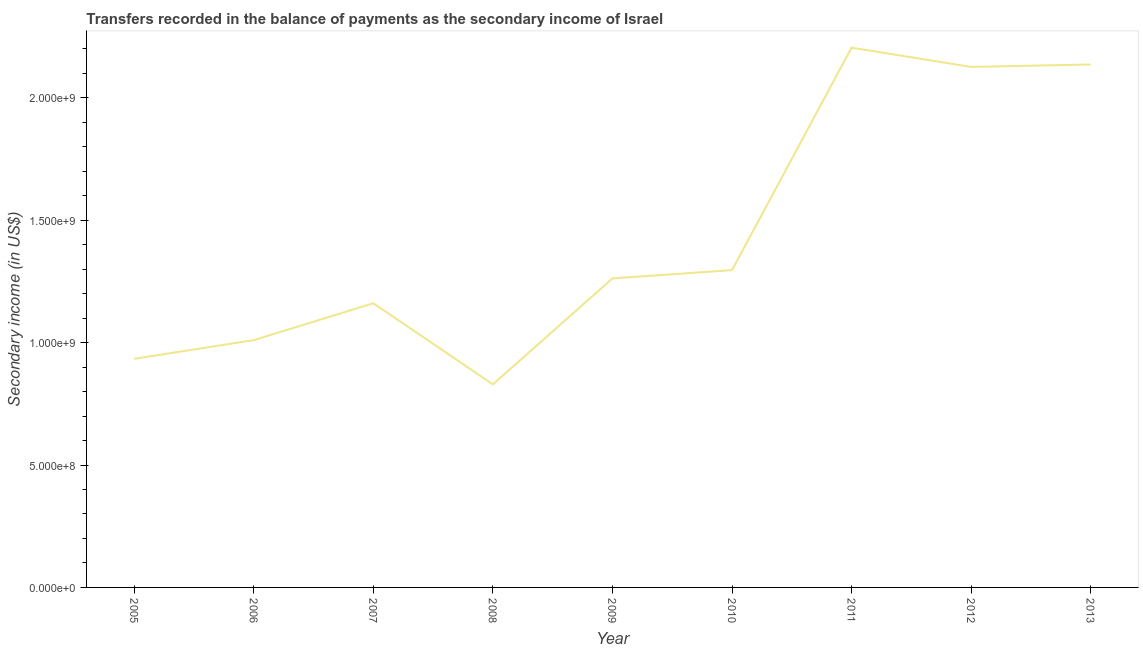What is the amount of secondary income in 2006?
Your response must be concise. 1.01e+09. Across all years, what is the maximum amount of secondary income?
Your answer should be compact. 2.21e+09. Across all years, what is the minimum amount of secondary income?
Provide a short and direct response. 8.30e+08. In which year was the amount of secondary income maximum?
Provide a short and direct response. 2011. What is the sum of the amount of secondary income?
Your response must be concise. 1.30e+1. What is the difference between the amount of secondary income in 2006 and 2007?
Offer a terse response. -1.51e+08. What is the average amount of secondary income per year?
Your answer should be compact. 1.44e+09. What is the median amount of secondary income?
Offer a very short reply. 1.26e+09. In how many years, is the amount of secondary income greater than 200000000 US$?
Give a very brief answer. 9. What is the ratio of the amount of secondary income in 2007 to that in 2011?
Give a very brief answer. 0.53. What is the difference between the highest and the second highest amount of secondary income?
Provide a succinct answer. 6.87e+07. Is the sum of the amount of secondary income in 2009 and 2012 greater than the maximum amount of secondary income across all years?
Offer a very short reply. Yes. What is the difference between the highest and the lowest amount of secondary income?
Your answer should be compact. 1.38e+09. In how many years, is the amount of secondary income greater than the average amount of secondary income taken over all years?
Make the answer very short. 3. What is the difference between two consecutive major ticks on the Y-axis?
Ensure brevity in your answer.  5.00e+08. Are the values on the major ticks of Y-axis written in scientific E-notation?
Keep it short and to the point. Yes. What is the title of the graph?
Ensure brevity in your answer.  Transfers recorded in the balance of payments as the secondary income of Israel. What is the label or title of the Y-axis?
Keep it short and to the point. Secondary income (in US$). What is the Secondary income (in US$) in 2005?
Your answer should be compact. 9.34e+08. What is the Secondary income (in US$) in 2006?
Keep it short and to the point. 1.01e+09. What is the Secondary income (in US$) of 2007?
Your answer should be very brief. 1.16e+09. What is the Secondary income (in US$) in 2008?
Your answer should be compact. 8.30e+08. What is the Secondary income (in US$) of 2009?
Your response must be concise. 1.26e+09. What is the Secondary income (in US$) in 2010?
Provide a succinct answer. 1.30e+09. What is the Secondary income (in US$) of 2011?
Make the answer very short. 2.21e+09. What is the Secondary income (in US$) of 2012?
Make the answer very short. 2.13e+09. What is the Secondary income (in US$) of 2013?
Keep it short and to the point. 2.14e+09. What is the difference between the Secondary income (in US$) in 2005 and 2006?
Offer a very short reply. -7.63e+07. What is the difference between the Secondary income (in US$) in 2005 and 2007?
Keep it short and to the point. -2.27e+08. What is the difference between the Secondary income (in US$) in 2005 and 2008?
Make the answer very short. 1.04e+08. What is the difference between the Secondary income (in US$) in 2005 and 2009?
Your answer should be compact. -3.28e+08. What is the difference between the Secondary income (in US$) in 2005 and 2010?
Your response must be concise. -3.62e+08. What is the difference between the Secondary income (in US$) in 2005 and 2011?
Provide a short and direct response. -1.27e+09. What is the difference between the Secondary income (in US$) in 2005 and 2012?
Keep it short and to the point. -1.19e+09. What is the difference between the Secondary income (in US$) in 2005 and 2013?
Provide a short and direct response. -1.20e+09. What is the difference between the Secondary income (in US$) in 2006 and 2007?
Your answer should be compact. -1.51e+08. What is the difference between the Secondary income (in US$) in 2006 and 2008?
Provide a short and direct response. 1.81e+08. What is the difference between the Secondary income (in US$) in 2006 and 2009?
Make the answer very short. -2.52e+08. What is the difference between the Secondary income (in US$) in 2006 and 2010?
Keep it short and to the point. -2.86e+08. What is the difference between the Secondary income (in US$) in 2006 and 2011?
Offer a very short reply. -1.19e+09. What is the difference between the Secondary income (in US$) in 2006 and 2012?
Give a very brief answer. -1.12e+09. What is the difference between the Secondary income (in US$) in 2006 and 2013?
Your answer should be very brief. -1.13e+09. What is the difference between the Secondary income (in US$) in 2007 and 2008?
Make the answer very short. 3.32e+08. What is the difference between the Secondary income (in US$) in 2007 and 2009?
Your answer should be very brief. -1.02e+08. What is the difference between the Secondary income (in US$) in 2007 and 2010?
Provide a succinct answer. -1.35e+08. What is the difference between the Secondary income (in US$) in 2007 and 2011?
Ensure brevity in your answer.  -1.04e+09. What is the difference between the Secondary income (in US$) in 2007 and 2012?
Ensure brevity in your answer.  -9.66e+08. What is the difference between the Secondary income (in US$) in 2007 and 2013?
Provide a short and direct response. -9.76e+08. What is the difference between the Secondary income (in US$) in 2008 and 2009?
Provide a succinct answer. -4.33e+08. What is the difference between the Secondary income (in US$) in 2008 and 2010?
Make the answer very short. -4.67e+08. What is the difference between the Secondary income (in US$) in 2008 and 2011?
Your response must be concise. -1.38e+09. What is the difference between the Secondary income (in US$) in 2008 and 2012?
Offer a terse response. -1.30e+09. What is the difference between the Secondary income (in US$) in 2008 and 2013?
Give a very brief answer. -1.31e+09. What is the difference between the Secondary income (in US$) in 2009 and 2010?
Give a very brief answer. -3.38e+07. What is the difference between the Secondary income (in US$) in 2009 and 2011?
Make the answer very short. -9.43e+08. What is the difference between the Secondary income (in US$) in 2009 and 2012?
Offer a very short reply. -8.64e+08. What is the difference between the Secondary income (in US$) in 2009 and 2013?
Provide a succinct answer. -8.74e+08. What is the difference between the Secondary income (in US$) in 2010 and 2011?
Make the answer very short. -9.09e+08. What is the difference between the Secondary income (in US$) in 2010 and 2012?
Give a very brief answer. -8.30e+08. What is the difference between the Secondary income (in US$) in 2010 and 2013?
Make the answer very short. -8.40e+08. What is the difference between the Secondary income (in US$) in 2011 and 2012?
Make the answer very short. 7.87e+07. What is the difference between the Secondary income (in US$) in 2011 and 2013?
Provide a succinct answer. 6.87e+07. What is the difference between the Secondary income (in US$) in 2012 and 2013?
Your answer should be very brief. -1.00e+07. What is the ratio of the Secondary income (in US$) in 2005 to that in 2006?
Give a very brief answer. 0.92. What is the ratio of the Secondary income (in US$) in 2005 to that in 2007?
Your response must be concise. 0.8. What is the ratio of the Secondary income (in US$) in 2005 to that in 2008?
Your answer should be very brief. 1.13. What is the ratio of the Secondary income (in US$) in 2005 to that in 2009?
Provide a succinct answer. 0.74. What is the ratio of the Secondary income (in US$) in 2005 to that in 2010?
Provide a succinct answer. 0.72. What is the ratio of the Secondary income (in US$) in 2005 to that in 2011?
Provide a short and direct response. 0.42. What is the ratio of the Secondary income (in US$) in 2005 to that in 2012?
Ensure brevity in your answer.  0.44. What is the ratio of the Secondary income (in US$) in 2005 to that in 2013?
Ensure brevity in your answer.  0.44. What is the ratio of the Secondary income (in US$) in 2006 to that in 2007?
Provide a succinct answer. 0.87. What is the ratio of the Secondary income (in US$) in 2006 to that in 2008?
Your answer should be very brief. 1.22. What is the ratio of the Secondary income (in US$) in 2006 to that in 2009?
Provide a succinct answer. 0.8. What is the ratio of the Secondary income (in US$) in 2006 to that in 2010?
Offer a terse response. 0.78. What is the ratio of the Secondary income (in US$) in 2006 to that in 2011?
Keep it short and to the point. 0.46. What is the ratio of the Secondary income (in US$) in 2006 to that in 2012?
Keep it short and to the point. 0.47. What is the ratio of the Secondary income (in US$) in 2006 to that in 2013?
Provide a succinct answer. 0.47. What is the ratio of the Secondary income (in US$) in 2007 to that in 2008?
Offer a very short reply. 1.4. What is the ratio of the Secondary income (in US$) in 2007 to that in 2010?
Offer a very short reply. 0.9. What is the ratio of the Secondary income (in US$) in 2007 to that in 2011?
Your response must be concise. 0.53. What is the ratio of the Secondary income (in US$) in 2007 to that in 2012?
Keep it short and to the point. 0.55. What is the ratio of the Secondary income (in US$) in 2007 to that in 2013?
Your response must be concise. 0.54. What is the ratio of the Secondary income (in US$) in 2008 to that in 2009?
Your answer should be very brief. 0.66. What is the ratio of the Secondary income (in US$) in 2008 to that in 2010?
Offer a very short reply. 0.64. What is the ratio of the Secondary income (in US$) in 2008 to that in 2011?
Offer a terse response. 0.38. What is the ratio of the Secondary income (in US$) in 2008 to that in 2012?
Offer a terse response. 0.39. What is the ratio of the Secondary income (in US$) in 2008 to that in 2013?
Offer a terse response. 0.39. What is the ratio of the Secondary income (in US$) in 2009 to that in 2010?
Ensure brevity in your answer.  0.97. What is the ratio of the Secondary income (in US$) in 2009 to that in 2011?
Ensure brevity in your answer.  0.57. What is the ratio of the Secondary income (in US$) in 2009 to that in 2012?
Your response must be concise. 0.59. What is the ratio of the Secondary income (in US$) in 2009 to that in 2013?
Offer a very short reply. 0.59. What is the ratio of the Secondary income (in US$) in 2010 to that in 2011?
Your answer should be very brief. 0.59. What is the ratio of the Secondary income (in US$) in 2010 to that in 2012?
Ensure brevity in your answer.  0.61. What is the ratio of the Secondary income (in US$) in 2010 to that in 2013?
Make the answer very short. 0.61. What is the ratio of the Secondary income (in US$) in 2011 to that in 2012?
Give a very brief answer. 1.04. What is the ratio of the Secondary income (in US$) in 2011 to that in 2013?
Your response must be concise. 1.03. What is the ratio of the Secondary income (in US$) in 2012 to that in 2013?
Your response must be concise. 0.99. 